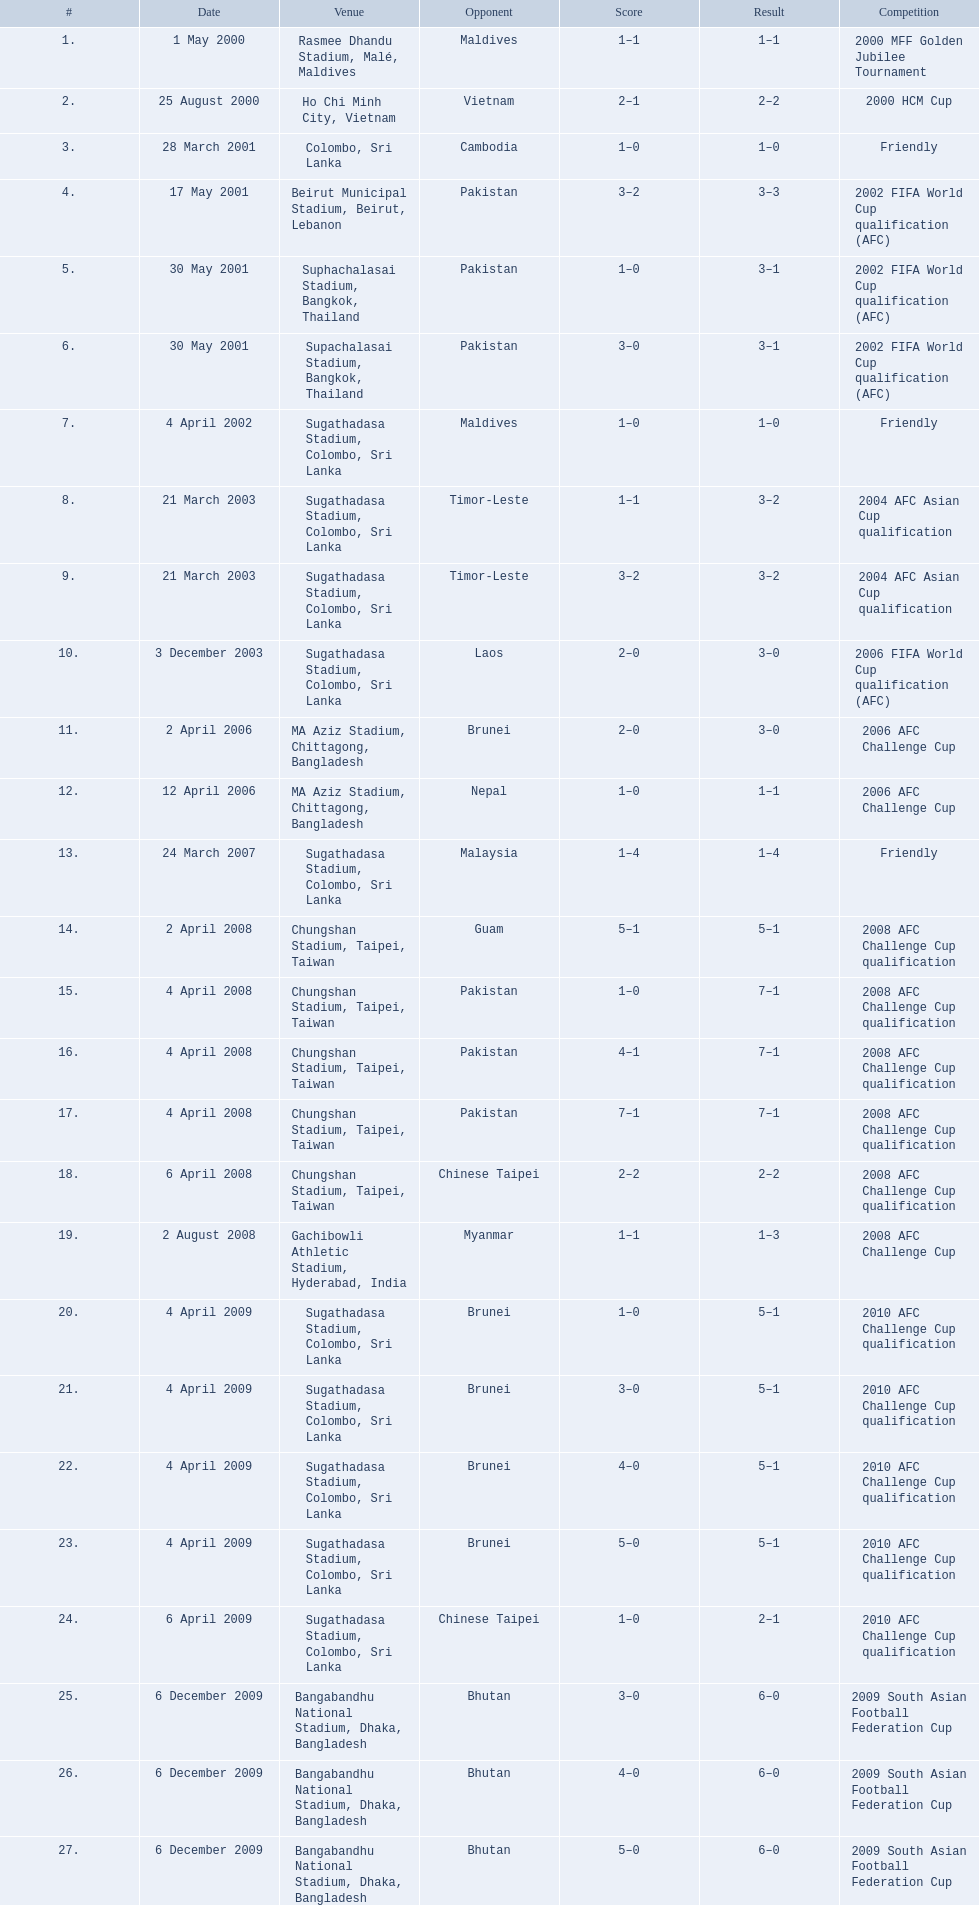What are the listed venues? Rasmee Dhandu Stadium, Malé, Maldives, Ho Chi Minh City, Vietnam, Colombo, Sri Lanka, Beirut Municipal Stadium, Beirut, Lebanon, Suphachalasai Stadium, Bangkok, Thailand, MA Aziz Stadium, Chittagong, Bangladesh, Sugathadasa Stadium, Colombo, Sri Lanka, Chungshan Stadium, Taipei, Taiwan, Gachibowli Athletic Stadium, Hyderabad, India, Sugathadasa Stadium, Colombo, Sri Lanka, Bangabandhu National Stadium, Dhaka, Bangladesh. Which one is ranked the highest? Rasmee Dhandu Stadium, Malé, Maldives. 